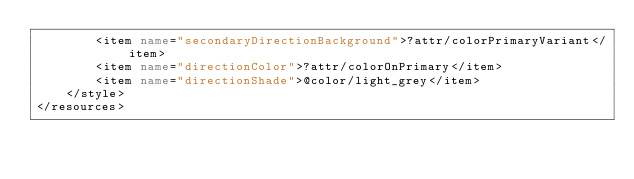Convert code to text. <code><loc_0><loc_0><loc_500><loc_500><_XML_>        <item name="secondaryDirectionBackground">?attr/colorPrimaryVariant</item>
        <item name="directionColor">?attr/colorOnPrimary</item>
        <item name="directionShade">@color/light_grey</item>
    </style>
</resources></code> 